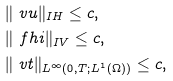<formula> <loc_0><loc_0><loc_500><loc_500>& \| \ v u \| _ { \L I H } \leq c , \\ & \| \ f h i \| _ { \L I V } \leq c , \\ & \| \ v t \| _ { L ^ { \infty } ( 0 , T ; L ^ { 1 } ( \Omega ) ) } \leq c ,</formula> 